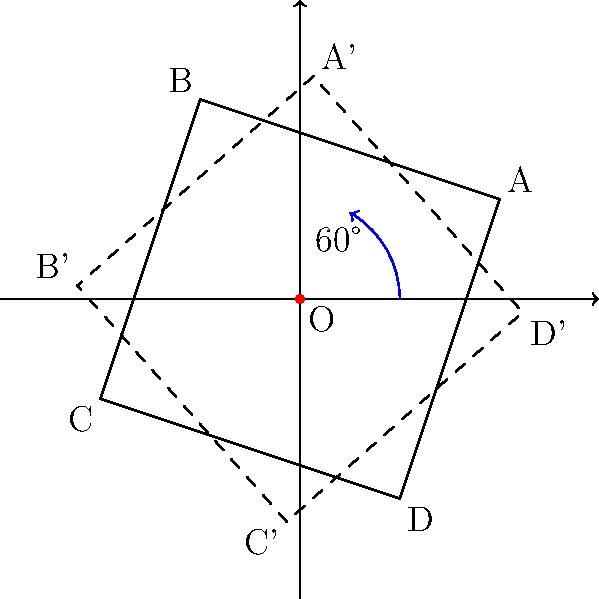A lost pet poster is represented by the quadrilateral ABCD in the figure. If the poster is rotated 60° counterclockwise around the origin O, what will be the coordinates of point A after the rotation? To find the coordinates of point A after a 60° counterclockwise rotation around the origin, we can follow these steps:

1. Identify the initial coordinates of point A: $(2, 1)$

2. Use the rotation matrix for a counterclockwise rotation of $\theta$ degrees:
   $$\begin{bmatrix} \cos\theta & -\sin\theta \\ \sin\theta & \cos\theta \end{bmatrix}$$

3. For a 60° rotation, $\theta = 60°$. We need to calculate:
   $\cos 60° = \frac{1}{2}$ and $\sin 60° = \frac{\sqrt{3}}{2}$

4. Apply the rotation matrix to the coordinates of A:
   $$\begin{bmatrix} \cos 60° & -\sin 60° \\ \sin 60° & \cos 60° \end{bmatrix} \begin{bmatrix} 2 \\ 1 \end{bmatrix}$$

5. Multiply the matrices:
   $$\begin{bmatrix} \frac{1}{2} & -\frac{\sqrt{3}}{2} \\ \frac{\sqrt{3}}{2} & \frac{1}{2} \end{bmatrix} \begin{bmatrix} 2 \\ 1 \end{bmatrix} = \begin{bmatrix} 2 \cdot \frac{1}{2} - 1 \cdot \frac{\sqrt{3}}{2} \\ 2 \cdot \frac{\sqrt{3}}{2} + 1 \cdot \frac{1}{2} \end{bmatrix}$$

6. Simplify:
   $$\begin{bmatrix} 1 - \frac{\sqrt{3}}{2} \\ \sqrt{3} + \frac{1}{2} \end{bmatrix}$$

Therefore, the coordinates of point A after the rotation are $(1 - \frac{\sqrt{3}}{2}, \sqrt{3} + \frac{1}{2})$.
Answer: $(1 - \frac{\sqrt{3}}{2}, \sqrt{3} + \frac{1}{2})$ 